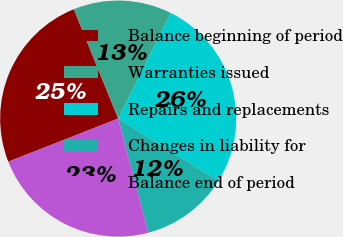Convert chart to OTSL. <chart><loc_0><loc_0><loc_500><loc_500><pie_chart><fcel>Balance beginning of period<fcel>Warranties issued<fcel>Repairs and replacements<fcel>Changes in liability for<fcel>Balance end of period<nl><fcel>24.82%<fcel>13.49%<fcel>26.49%<fcel>12.04%<fcel>23.16%<nl></chart> 